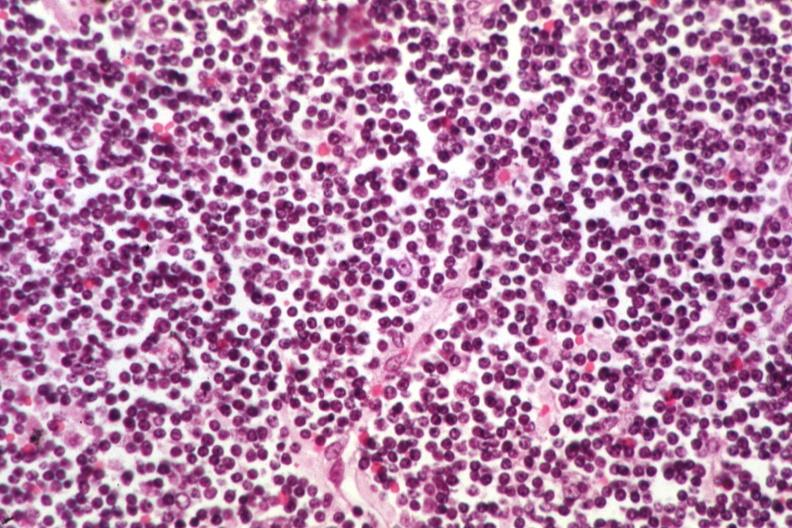s chronic lymphocytic leukemia present?
Answer the question using a single word or phrase. Yes 